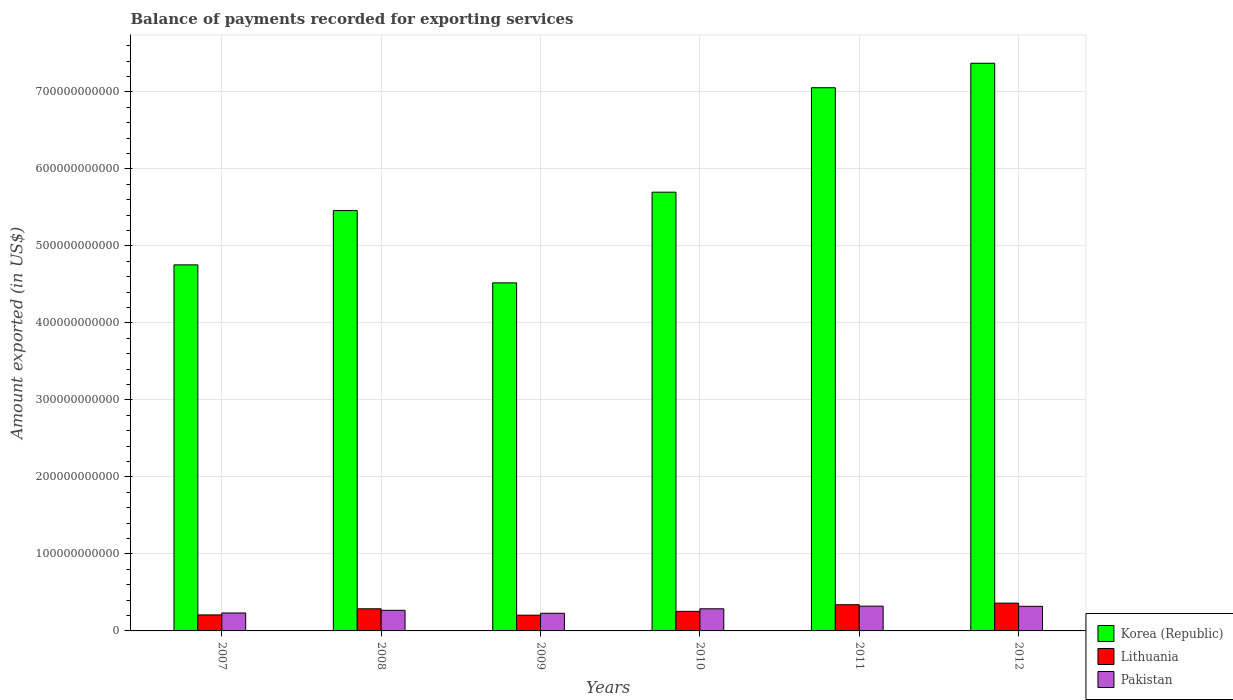Are the number of bars per tick equal to the number of legend labels?
Your answer should be very brief. Yes. In how many cases, is the number of bars for a given year not equal to the number of legend labels?
Give a very brief answer. 0. What is the amount exported in Pakistan in 2012?
Ensure brevity in your answer.  3.20e+1. Across all years, what is the maximum amount exported in Pakistan?
Provide a succinct answer. 3.22e+1. Across all years, what is the minimum amount exported in Pakistan?
Your response must be concise. 2.29e+1. In which year was the amount exported in Lithuania minimum?
Offer a very short reply. 2009. What is the total amount exported in Pakistan in the graph?
Your answer should be compact. 1.66e+11. What is the difference between the amount exported in Lithuania in 2007 and that in 2009?
Offer a terse response. 3.30e+08. What is the difference between the amount exported in Korea (Republic) in 2011 and the amount exported in Lithuania in 2007?
Ensure brevity in your answer.  6.85e+11. What is the average amount exported in Pakistan per year?
Your answer should be compact. 2.76e+1. In the year 2007, what is the difference between the amount exported in Korea (Republic) and amount exported in Pakistan?
Make the answer very short. 4.52e+11. What is the ratio of the amount exported in Korea (Republic) in 2008 to that in 2012?
Provide a succinct answer. 0.74. Is the amount exported in Lithuania in 2011 less than that in 2012?
Your response must be concise. Yes. Is the difference between the amount exported in Korea (Republic) in 2007 and 2011 greater than the difference between the amount exported in Pakistan in 2007 and 2011?
Provide a short and direct response. No. What is the difference between the highest and the second highest amount exported in Korea (Republic)?
Your response must be concise. 3.18e+1. What is the difference between the highest and the lowest amount exported in Lithuania?
Give a very brief answer. 1.56e+1. In how many years, is the amount exported in Korea (Republic) greater than the average amount exported in Korea (Republic) taken over all years?
Ensure brevity in your answer.  2. What does the 1st bar from the left in 2011 represents?
Your answer should be compact. Korea (Republic). How many bars are there?
Your response must be concise. 18. Are all the bars in the graph horizontal?
Keep it short and to the point. No. What is the difference between two consecutive major ticks on the Y-axis?
Ensure brevity in your answer.  1.00e+11. Are the values on the major ticks of Y-axis written in scientific E-notation?
Your response must be concise. No. Does the graph contain any zero values?
Offer a terse response. No. Does the graph contain grids?
Make the answer very short. Yes. Where does the legend appear in the graph?
Your response must be concise. Bottom right. How many legend labels are there?
Your response must be concise. 3. How are the legend labels stacked?
Provide a succinct answer. Vertical. What is the title of the graph?
Ensure brevity in your answer.  Balance of payments recorded for exporting services. What is the label or title of the X-axis?
Your answer should be very brief. Years. What is the label or title of the Y-axis?
Provide a short and direct response. Amount exported (in US$). What is the Amount exported (in US$) of Korea (Republic) in 2007?
Ensure brevity in your answer.  4.75e+11. What is the Amount exported (in US$) in Lithuania in 2007?
Keep it short and to the point. 2.08e+1. What is the Amount exported (in US$) in Pakistan in 2007?
Keep it short and to the point. 2.33e+1. What is the Amount exported (in US$) in Korea (Republic) in 2008?
Offer a terse response. 5.46e+11. What is the Amount exported (in US$) of Lithuania in 2008?
Provide a short and direct response. 2.87e+1. What is the Amount exported (in US$) of Pakistan in 2008?
Offer a terse response. 2.68e+1. What is the Amount exported (in US$) in Korea (Republic) in 2009?
Your answer should be compact. 4.52e+11. What is the Amount exported (in US$) in Lithuania in 2009?
Keep it short and to the point. 2.04e+1. What is the Amount exported (in US$) of Pakistan in 2009?
Keep it short and to the point. 2.29e+1. What is the Amount exported (in US$) in Korea (Republic) in 2010?
Your answer should be compact. 5.70e+11. What is the Amount exported (in US$) of Lithuania in 2010?
Ensure brevity in your answer.  2.54e+1. What is the Amount exported (in US$) in Pakistan in 2010?
Offer a very short reply. 2.87e+1. What is the Amount exported (in US$) of Korea (Republic) in 2011?
Offer a very short reply. 7.05e+11. What is the Amount exported (in US$) of Lithuania in 2011?
Your answer should be compact. 3.40e+1. What is the Amount exported (in US$) of Pakistan in 2011?
Your answer should be very brief. 3.22e+1. What is the Amount exported (in US$) in Korea (Republic) in 2012?
Provide a short and direct response. 7.37e+11. What is the Amount exported (in US$) of Lithuania in 2012?
Offer a very short reply. 3.61e+1. What is the Amount exported (in US$) of Pakistan in 2012?
Make the answer very short. 3.20e+1. Across all years, what is the maximum Amount exported (in US$) of Korea (Republic)?
Your answer should be compact. 7.37e+11. Across all years, what is the maximum Amount exported (in US$) in Lithuania?
Give a very brief answer. 3.61e+1. Across all years, what is the maximum Amount exported (in US$) in Pakistan?
Ensure brevity in your answer.  3.22e+1. Across all years, what is the minimum Amount exported (in US$) of Korea (Republic)?
Your response must be concise. 4.52e+11. Across all years, what is the minimum Amount exported (in US$) of Lithuania?
Your answer should be very brief. 2.04e+1. Across all years, what is the minimum Amount exported (in US$) of Pakistan?
Offer a terse response. 2.29e+1. What is the total Amount exported (in US$) in Korea (Republic) in the graph?
Provide a succinct answer. 3.49e+12. What is the total Amount exported (in US$) of Lithuania in the graph?
Offer a terse response. 1.65e+11. What is the total Amount exported (in US$) in Pakistan in the graph?
Your answer should be compact. 1.66e+11. What is the difference between the Amount exported (in US$) in Korea (Republic) in 2007 and that in 2008?
Your response must be concise. -7.05e+1. What is the difference between the Amount exported (in US$) of Lithuania in 2007 and that in 2008?
Provide a succinct answer. -7.95e+09. What is the difference between the Amount exported (in US$) in Pakistan in 2007 and that in 2008?
Your response must be concise. -3.45e+09. What is the difference between the Amount exported (in US$) in Korea (Republic) in 2007 and that in 2009?
Provide a succinct answer. 2.34e+1. What is the difference between the Amount exported (in US$) of Lithuania in 2007 and that in 2009?
Your answer should be very brief. 3.30e+08. What is the difference between the Amount exported (in US$) in Pakistan in 2007 and that in 2009?
Offer a very short reply. 3.81e+08. What is the difference between the Amount exported (in US$) of Korea (Republic) in 2007 and that in 2010?
Your answer should be very brief. -9.44e+1. What is the difference between the Amount exported (in US$) in Lithuania in 2007 and that in 2010?
Offer a terse response. -4.61e+09. What is the difference between the Amount exported (in US$) of Pakistan in 2007 and that in 2010?
Offer a terse response. -5.44e+09. What is the difference between the Amount exported (in US$) of Korea (Republic) in 2007 and that in 2011?
Provide a short and direct response. -2.30e+11. What is the difference between the Amount exported (in US$) in Lithuania in 2007 and that in 2011?
Ensure brevity in your answer.  -1.32e+1. What is the difference between the Amount exported (in US$) in Pakistan in 2007 and that in 2011?
Make the answer very short. -8.87e+09. What is the difference between the Amount exported (in US$) in Korea (Republic) in 2007 and that in 2012?
Offer a terse response. -2.62e+11. What is the difference between the Amount exported (in US$) of Lithuania in 2007 and that in 2012?
Make the answer very short. -1.53e+1. What is the difference between the Amount exported (in US$) of Pakistan in 2007 and that in 2012?
Your response must be concise. -8.66e+09. What is the difference between the Amount exported (in US$) in Korea (Republic) in 2008 and that in 2009?
Give a very brief answer. 9.39e+1. What is the difference between the Amount exported (in US$) of Lithuania in 2008 and that in 2009?
Give a very brief answer. 8.28e+09. What is the difference between the Amount exported (in US$) of Pakistan in 2008 and that in 2009?
Offer a terse response. 3.83e+09. What is the difference between the Amount exported (in US$) in Korea (Republic) in 2008 and that in 2010?
Provide a short and direct response. -2.39e+1. What is the difference between the Amount exported (in US$) of Lithuania in 2008 and that in 2010?
Provide a succinct answer. 3.34e+09. What is the difference between the Amount exported (in US$) in Pakistan in 2008 and that in 2010?
Give a very brief answer. -1.98e+09. What is the difference between the Amount exported (in US$) in Korea (Republic) in 2008 and that in 2011?
Your answer should be very brief. -1.60e+11. What is the difference between the Amount exported (in US$) of Lithuania in 2008 and that in 2011?
Keep it short and to the point. -5.27e+09. What is the difference between the Amount exported (in US$) in Pakistan in 2008 and that in 2011?
Offer a terse response. -5.42e+09. What is the difference between the Amount exported (in US$) in Korea (Republic) in 2008 and that in 2012?
Make the answer very short. -1.91e+11. What is the difference between the Amount exported (in US$) of Lithuania in 2008 and that in 2012?
Make the answer very short. -7.36e+09. What is the difference between the Amount exported (in US$) in Pakistan in 2008 and that in 2012?
Provide a succinct answer. -5.21e+09. What is the difference between the Amount exported (in US$) of Korea (Republic) in 2009 and that in 2010?
Give a very brief answer. -1.18e+11. What is the difference between the Amount exported (in US$) in Lithuania in 2009 and that in 2010?
Keep it short and to the point. -4.94e+09. What is the difference between the Amount exported (in US$) in Pakistan in 2009 and that in 2010?
Your answer should be compact. -5.82e+09. What is the difference between the Amount exported (in US$) of Korea (Republic) in 2009 and that in 2011?
Make the answer very short. -2.53e+11. What is the difference between the Amount exported (in US$) of Lithuania in 2009 and that in 2011?
Give a very brief answer. -1.36e+1. What is the difference between the Amount exported (in US$) in Pakistan in 2009 and that in 2011?
Provide a short and direct response. -9.25e+09. What is the difference between the Amount exported (in US$) of Korea (Republic) in 2009 and that in 2012?
Your response must be concise. -2.85e+11. What is the difference between the Amount exported (in US$) in Lithuania in 2009 and that in 2012?
Give a very brief answer. -1.56e+1. What is the difference between the Amount exported (in US$) in Pakistan in 2009 and that in 2012?
Offer a terse response. -9.04e+09. What is the difference between the Amount exported (in US$) of Korea (Republic) in 2010 and that in 2011?
Provide a succinct answer. -1.36e+11. What is the difference between the Amount exported (in US$) in Lithuania in 2010 and that in 2011?
Your answer should be compact. -8.61e+09. What is the difference between the Amount exported (in US$) in Pakistan in 2010 and that in 2011?
Your answer should be compact. -3.44e+09. What is the difference between the Amount exported (in US$) in Korea (Republic) in 2010 and that in 2012?
Provide a succinct answer. -1.67e+11. What is the difference between the Amount exported (in US$) in Lithuania in 2010 and that in 2012?
Keep it short and to the point. -1.07e+1. What is the difference between the Amount exported (in US$) in Pakistan in 2010 and that in 2012?
Make the answer very short. -3.22e+09. What is the difference between the Amount exported (in US$) of Korea (Republic) in 2011 and that in 2012?
Your response must be concise. -3.18e+1. What is the difference between the Amount exported (in US$) of Lithuania in 2011 and that in 2012?
Offer a very short reply. -2.09e+09. What is the difference between the Amount exported (in US$) of Pakistan in 2011 and that in 2012?
Keep it short and to the point. 2.12e+08. What is the difference between the Amount exported (in US$) in Korea (Republic) in 2007 and the Amount exported (in US$) in Lithuania in 2008?
Keep it short and to the point. 4.47e+11. What is the difference between the Amount exported (in US$) of Korea (Republic) in 2007 and the Amount exported (in US$) of Pakistan in 2008?
Your answer should be very brief. 4.49e+11. What is the difference between the Amount exported (in US$) in Lithuania in 2007 and the Amount exported (in US$) in Pakistan in 2008?
Provide a short and direct response. -5.98e+09. What is the difference between the Amount exported (in US$) in Korea (Republic) in 2007 and the Amount exported (in US$) in Lithuania in 2009?
Give a very brief answer. 4.55e+11. What is the difference between the Amount exported (in US$) in Korea (Republic) in 2007 and the Amount exported (in US$) in Pakistan in 2009?
Ensure brevity in your answer.  4.52e+11. What is the difference between the Amount exported (in US$) in Lithuania in 2007 and the Amount exported (in US$) in Pakistan in 2009?
Provide a short and direct response. -2.14e+09. What is the difference between the Amount exported (in US$) in Korea (Republic) in 2007 and the Amount exported (in US$) in Lithuania in 2010?
Ensure brevity in your answer.  4.50e+11. What is the difference between the Amount exported (in US$) of Korea (Republic) in 2007 and the Amount exported (in US$) of Pakistan in 2010?
Give a very brief answer. 4.47e+11. What is the difference between the Amount exported (in US$) in Lithuania in 2007 and the Amount exported (in US$) in Pakistan in 2010?
Make the answer very short. -7.96e+09. What is the difference between the Amount exported (in US$) of Korea (Republic) in 2007 and the Amount exported (in US$) of Lithuania in 2011?
Ensure brevity in your answer.  4.41e+11. What is the difference between the Amount exported (in US$) of Korea (Republic) in 2007 and the Amount exported (in US$) of Pakistan in 2011?
Your answer should be compact. 4.43e+11. What is the difference between the Amount exported (in US$) of Lithuania in 2007 and the Amount exported (in US$) of Pakistan in 2011?
Your answer should be compact. -1.14e+1. What is the difference between the Amount exported (in US$) in Korea (Republic) in 2007 and the Amount exported (in US$) in Lithuania in 2012?
Provide a succinct answer. 4.39e+11. What is the difference between the Amount exported (in US$) of Korea (Republic) in 2007 and the Amount exported (in US$) of Pakistan in 2012?
Ensure brevity in your answer.  4.43e+11. What is the difference between the Amount exported (in US$) of Lithuania in 2007 and the Amount exported (in US$) of Pakistan in 2012?
Offer a very short reply. -1.12e+1. What is the difference between the Amount exported (in US$) in Korea (Republic) in 2008 and the Amount exported (in US$) in Lithuania in 2009?
Keep it short and to the point. 5.25e+11. What is the difference between the Amount exported (in US$) of Korea (Republic) in 2008 and the Amount exported (in US$) of Pakistan in 2009?
Your response must be concise. 5.23e+11. What is the difference between the Amount exported (in US$) in Lithuania in 2008 and the Amount exported (in US$) in Pakistan in 2009?
Make the answer very short. 5.81e+09. What is the difference between the Amount exported (in US$) of Korea (Republic) in 2008 and the Amount exported (in US$) of Lithuania in 2010?
Make the answer very short. 5.21e+11. What is the difference between the Amount exported (in US$) of Korea (Republic) in 2008 and the Amount exported (in US$) of Pakistan in 2010?
Your answer should be compact. 5.17e+11. What is the difference between the Amount exported (in US$) in Lithuania in 2008 and the Amount exported (in US$) in Pakistan in 2010?
Offer a terse response. -5.87e+06. What is the difference between the Amount exported (in US$) of Korea (Republic) in 2008 and the Amount exported (in US$) of Lithuania in 2011?
Provide a short and direct response. 5.12e+11. What is the difference between the Amount exported (in US$) in Korea (Republic) in 2008 and the Amount exported (in US$) in Pakistan in 2011?
Keep it short and to the point. 5.14e+11. What is the difference between the Amount exported (in US$) in Lithuania in 2008 and the Amount exported (in US$) in Pakistan in 2011?
Offer a very short reply. -3.44e+09. What is the difference between the Amount exported (in US$) of Korea (Republic) in 2008 and the Amount exported (in US$) of Lithuania in 2012?
Offer a very short reply. 5.10e+11. What is the difference between the Amount exported (in US$) of Korea (Republic) in 2008 and the Amount exported (in US$) of Pakistan in 2012?
Provide a short and direct response. 5.14e+11. What is the difference between the Amount exported (in US$) of Lithuania in 2008 and the Amount exported (in US$) of Pakistan in 2012?
Make the answer very short. -3.23e+09. What is the difference between the Amount exported (in US$) in Korea (Republic) in 2009 and the Amount exported (in US$) in Lithuania in 2010?
Offer a very short reply. 4.27e+11. What is the difference between the Amount exported (in US$) in Korea (Republic) in 2009 and the Amount exported (in US$) in Pakistan in 2010?
Your answer should be very brief. 4.23e+11. What is the difference between the Amount exported (in US$) of Lithuania in 2009 and the Amount exported (in US$) of Pakistan in 2010?
Your response must be concise. -8.29e+09. What is the difference between the Amount exported (in US$) in Korea (Republic) in 2009 and the Amount exported (in US$) in Lithuania in 2011?
Your answer should be compact. 4.18e+11. What is the difference between the Amount exported (in US$) in Korea (Republic) in 2009 and the Amount exported (in US$) in Pakistan in 2011?
Offer a very short reply. 4.20e+11. What is the difference between the Amount exported (in US$) of Lithuania in 2009 and the Amount exported (in US$) of Pakistan in 2011?
Your response must be concise. -1.17e+1. What is the difference between the Amount exported (in US$) in Korea (Republic) in 2009 and the Amount exported (in US$) in Lithuania in 2012?
Ensure brevity in your answer.  4.16e+11. What is the difference between the Amount exported (in US$) of Korea (Republic) in 2009 and the Amount exported (in US$) of Pakistan in 2012?
Provide a succinct answer. 4.20e+11. What is the difference between the Amount exported (in US$) of Lithuania in 2009 and the Amount exported (in US$) of Pakistan in 2012?
Ensure brevity in your answer.  -1.15e+1. What is the difference between the Amount exported (in US$) of Korea (Republic) in 2010 and the Amount exported (in US$) of Lithuania in 2011?
Your answer should be compact. 5.36e+11. What is the difference between the Amount exported (in US$) in Korea (Republic) in 2010 and the Amount exported (in US$) in Pakistan in 2011?
Provide a succinct answer. 5.38e+11. What is the difference between the Amount exported (in US$) of Lithuania in 2010 and the Amount exported (in US$) of Pakistan in 2011?
Ensure brevity in your answer.  -6.78e+09. What is the difference between the Amount exported (in US$) of Korea (Republic) in 2010 and the Amount exported (in US$) of Lithuania in 2012?
Provide a succinct answer. 5.34e+11. What is the difference between the Amount exported (in US$) of Korea (Republic) in 2010 and the Amount exported (in US$) of Pakistan in 2012?
Offer a very short reply. 5.38e+11. What is the difference between the Amount exported (in US$) of Lithuania in 2010 and the Amount exported (in US$) of Pakistan in 2012?
Offer a very short reply. -6.57e+09. What is the difference between the Amount exported (in US$) in Korea (Republic) in 2011 and the Amount exported (in US$) in Lithuania in 2012?
Your answer should be very brief. 6.69e+11. What is the difference between the Amount exported (in US$) in Korea (Republic) in 2011 and the Amount exported (in US$) in Pakistan in 2012?
Provide a short and direct response. 6.73e+11. What is the difference between the Amount exported (in US$) of Lithuania in 2011 and the Amount exported (in US$) of Pakistan in 2012?
Your response must be concise. 2.04e+09. What is the average Amount exported (in US$) of Korea (Republic) per year?
Your answer should be very brief. 5.81e+11. What is the average Amount exported (in US$) in Lithuania per year?
Make the answer very short. 2.76e+1. What is the average Amount exported (in US$) of Pakistan per year?
Provide a succinct answer. 2.76e+1. In the year 2007, what is the difference between the Amount exported (in US$) of Korea (Republic) and Amount exported (in US$) of Lithuania?
Provide a short and direct response. 4.55e+11. In the year 2007, what is the difference between the Amount exported (in US$) of Korea (Republic) and Amount exported (in US$) of Pakistan?
Your answer should be compact. 4.52e+11. In the year 2007, what is the difference between the Amount exported (in US$) in Lithuania and Amount exported (in US$) in Pakistan?
Provide a short and direct response. -2.52e+09. In the year 2008, what is the difference between the Amount exported (in US$) of Korea (Republic) and Amount exported (in US$) of Lithuania?
Your response must be concise. 5.17e+11. In the year 2008, what is the difference between the Amount exported (in US$) of Korea (Republic) and Amount exported (in US$) of Pakistan?
Ensure brevity in your answer.  5.19e+11. In the year 2008, what is the difference between the Amount exported (in US$) of Lithuania and Amount exported (in US$) of Pakistan?
Ensure brevity in your answer.  1.98e+09. In the year 2009, what is the difference between the Amount exported (in US$) of Korea (Republic) and Amount exported (in US$) of Lithuania?
Your answer should be very brief. 4.32e+11. In the year 2009, what is the difference between the Amount exported (in US$) of Korea (Republic) and Amount exported (in US$) of Pakistan?
Ensure brevity in your answer.  4.29e+11. In the year 2009, what is the difference between the Amount exported (in US$) in Lithuania and Amount exported (in US$) in Pakistan?
Your answer should be very brief. -2.47e+09. In the year 2010, what is the difference between the Amount exported (in US$) of Korea (Republic) and Amount exported (in US$) of Lithuania?
Make the answer very short. 5.44e+11. In the year 2010, what is the difference between the Amount exported (in US$) in Korea (Republic) and Amount exported (in US$) in Pakistan?
Offer a terse response. 5.41e+11. In the year 2010, what is the difference between the Amount exported (in US$) in Lithuania and Amount exported (in US$) in Pakistan?
Give a very brief answer. -3.35e+09. In the year 2011, what is the difference between the Amount exported (in US$) in Korea (Republic) and Amount exported (in US$) in Lithuania?
Give a very brief answer. 6.71e+11. In the year 2011, what is the difference between the Amount exported (in US$) in Korea (Republic) and Amount exported (in US$) in Pakistan?
Your response must be concise. 6.73e+11. In the year 2011, what is the difference between the Amount exported (in US$) of Lithuania and Amount exported (in US$) of Pakistan?
Offer a very short reply. 1.83e+09. In the year 2012, what is the difference between the Amount exported (in US$) in Korea (Republic) and Amount exported (in US$) in Lithuania?
Offer a terse response. 7.01e+11. In the year 2012, what is the difference between the Amount exported (in US$) of Korea (Republic) and Amount exported (in US$) of Pakistan?
Your answer should be compact. 7.05e+11. In the year 2012, what is the difference between the Amount exported (in US$) in Lithuania and Amount exported (in US$) in Pakistan?
Offer a terse response. 4.13e+09. What is the ratio of the Amount exported (in US$) of Korea (Republic) in 2007 to that in 2008?
Give a very brief answer. 0.87. What is the ratio of the Amount exported (in US$) in Lithuania in 2007 to that in 2008?
Make the answer very short. 0.72. What is the ratio of the Amount exported (in US$) of Pakistan in 2007 to that in 2008?
Your answer should be very brief. 0.87. What is the ratio of the Amount exported (in US$) in Korea (Republic) in 2007 to that in 2009?
Your response must be concise. 1.05. What is the ratio of the Amount exported (in US$) in Lithuania in 2007 to that in 2009?
Give a very brief answer. 1.02. What is the ratio of the Amount exported (in US$) in Pakistan in 2007 to that in 2009?
Your answer should be compact. 1.02. What is the ratio of the Amount exported (in US$) in Korea (Republic) in 2007 to that in 2010?
Offer a very short reply. 0.83. What is the ratio of the Amount exported (in US$) in Lithuania in 2007 to that in 2010?
Keep it short and to the point. 0.82. What is the ratio of the Amount exported (in US$) of Pakistan in 2007 to that in 2010?
Your answer should be compact. 0.81. What is the ratio of the Amount exported (in US$) of Korea (Republic) in 2007 to that in 2011?
Ensure brevity in your answer.  0.67. What is the ratio of the Amount exported (in US$) in Lithuania in 2007 to that in 2011?
Your answer should be very brief. 0.61. What is the ratio of the Amount exported (in US$) in Pakistan in 2007 to that in 2011?
Your answer should be compact. 0.72. What is the ratio of the Amount exported (in US$) in Korea (Republic) in 2007 to that in 2012?
Keep it short and to the point. 0.64. What is the ratio of the Amount exported (in US$) in Lithuania in 2007 to that in 2012?
Your response must be concise. 0.58. What is the ratio of the Amount exported (in US$) in Pakistan in 2007 to that in 2012?
Offer a terse response. 0.73. What is the ratio of the Amount exported (in US$) of Korea (Republic) in 2008 to that in 2009?
Your response must be concise. 1.21. What is the ratio of the Amount exported (in US$) of Lithuania in 2008 to that in 2009?
Give a very brief answer. 1.41. What is the ratio of the Amount exported (in US$) of Pakistan in 2008 to that in 2009?
Offer a very short reply. 1.17. What is the ratio of the Amount exported (in US$) in Korea (Republic) in 2008 to that in 2010?
Give a very brief answer. 0.96. What is the ratio of the Amount exported (in US$) of Lithuania in 2008 to that in 2010?
Your answer should be very brief. 1.13. What is the ratio of the Amount exported (in US$) in Pakistan in 2008 to that in 2010?
Offer a terse response. 0.93. What is the ratio of the Amount exported (in US$) of Korea (Republic) in 2008 to that in 2011?
Give a very brief answer. 0.77. What is the ratio of the Amount exported (in US$) in Lithuania in 2008 to that in 2011?
Ensure brevity in your answer.  0.84. What is the ratio of the Amount exported (in US$) of Pakistan in 2008 to that in 2011?
Ensure brevity in your answer.  0.83. What is the ratio of the Amount exported (in US$) in Korea (Republic) in 2008 to that in 2012?
Give a very brief answer. 0.74. What is the ratio of the Amount exported (in US$) in Lithuania in 2008 to that in 2012?
Give a very brief answer. 0.8. What is the ratio of the Amount exported (in US$) in Pakistan in 2008 to that in 2012?
Keep it short and to the point. 0.84. What is the ratio of the Amount exported (in US$) of Korea (Republic) in 2009 to that in 2010?
Make the answer very short. 0.79. What is the ratio of the Amount exported (in US$) of Lithuania in 2009 to that in 2010?
Give a very brief answer. 0.81. What is the ratio of the Amount exported (in US$) of Pakistan in 2009 to that in 2010?
Offer a terse response. 0.8. What is the ratio of the Amount exported (in US$) in Korea (Republic) in 2009 to that in 2011?
Offer a terse response. 0.64. What is the ratio of the Amount exported (in US$) in Lithuania in 2009 to that in 2011?
Provide a short and direct response. 0.6. What is the ratio of the Amount exported (in US$) in Pakistan in 2009 to that in 2011?
Your answer should be compact. 0.71. What is the ratio of the Amount exported (in US$) in Korea (Republic) in 2009 to that in 2012?
Offer a terse response. 0.61. What is the ratio of the Amount exported (in US$) of Lithuania in 2009 to that in 2012?
Offer a very short reply. 0.57. What is the ratio of the Amount exported (in US$) of Pakistan in 2009 to that in 2012?
Give a very brief answer. 0.72. What is the ratio of the Amount exported (in US$) of Korea (Republic) in 2010 to that in 2011?
Your answer should be compact. 0.81. What is the ratio of the Amount exported (in US$) in Lithuania in 2010 to that in 2011?
Your answer should be very brief. 0.75. What is the ratio of the Amount exported (in US$) of Pakistan in 2010 to that in 2011?
Keep it short and to the point. 0.89. What is the ratio of the Amount exported (in US$) of Korea (Republic) in 2010 to that in 2012?
Your answer should be compact. 0.77. What is the ratio of the Amount exported (in US$) of Lithuania in 2010 to that in 2012?
Give a very brief answer. 0.7. What is the ratio of the Amount exported (in US$) in Pakistan in 2010 to that in 2012?
Your response must be concise. 0.9. What is the ratio of the Amount exported (in US$) in Korea (Republic) in 2011 to that in 2012?
Offer a terse response. 0.96. What is the ratio of the Amount exported (in US$) of Lithuania in 2011 to that in 2012?
Your answer should be compact. 0.94. What is the ratio of the Amount exported (in US$) of Pakistan in 2011 to that in 2012?
Provide a succinct answer. 1.01. What is the difference between the highest and the second highest Amount exported (in US$) of Korea (Republic)?
Provide a short and direct response. 3.18e+1. What is the difference between the highest and the second highest Amount exported (in US$) of Lithuania?
Your response must be concise. 2.09e+09. What is the difference between the highest and the second highest Amount exported (in US$) of Pakistan?
Make the answer very short. 2.12e+08. What is the difference between the highest and the lowest Amount exported (in US$) in Korea (Republic)?
Your response must be concise. 2.85e+11. What is the difference between the highest and the lowest Amount exported (in US$) in Lithuania?
Make the answer very short. 1.56e+1. What is the difference between the highest and the lowest Amount exported (in US$) in Pakistan?
Ensure brevity in your answer.  9.25e+09. 